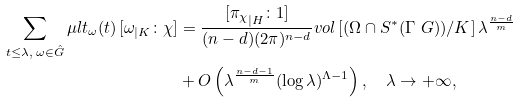Convert formula to latex. <formula><loc_0><loc_0><loc_500><loc_500>\sum _ { t \leq \lambda , \, \omega \in \hat { G } } \mu l t _ { \omega } ( t ) \, [ \omega _ { | K } \colon \chi ] & = \frac { [ { \pi _ { \chi } } _ { | H } \colon 1 ] } { ( n - d ) ( 2 \pi ) ^ { n - d } } v o l \, [ ( \Omega \cap S ^ { \ast } ( \Gamma \ G ) ) / K ] \, { \lambda } ^ { \frac { n - d } m } \\ & + O \left ( \lambda ^ { \frac { n - d - 1 } m } ( \log \lambda ) ^ { \Lambda - 1 } \right ) , \quad \lambda \to + \infty ,</formula> 